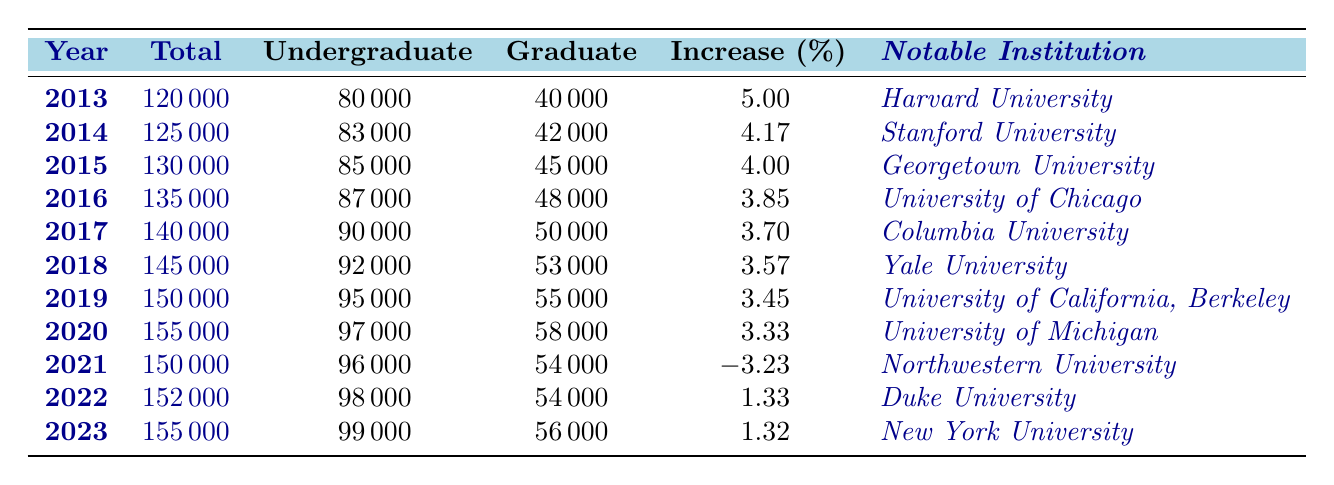What was the total enrollment in 2016? The table shows that the total enrollment for the year 2016 is indicated in the relevant row. It lists "135000" as the total enrollment figure for that year.
Answer: 135000 Which institution had the highest enrollment in 2019? By examining the entries, the notable institution for the year 2019 is listed as "University of California, Berkeley," which also has a total enrollment of 150000.
Answer: University of California, Berkeley What is the increase percentage from 2013 to 2014? The increase percentage for 2014 is listed directly in the table. From 2013, a total enrollment of 120000 increased to 125000 in 2014; thus, the increase percentage noted for 2014 is 4.17.
Answer: 4.17 What was the average graduate enrollment over the last decade? To find the average graduate enrollment, sum the graduate enrollments from 2013 to 2023, then divide by the number of years (11). The total is (40000 + 42000 + 45000 + 48000 + 50000 + 53000 + 55000 + 58000 + 54000 + 54000 + 56000) = 606000. Dividing this by 11 gives 606000/11 = 55272.73.
Answer: 55272.73 Did total enrollment decrease in 2021? Looking at the total enrollment values, 2021 shows "150000," while 2020 shows "155000." Since 150000 is less than 155000, this indicates a decrease.
Answer: Yes What were the enrollment trends from 2020 to 2023? The total enrollment for 2020 is 155000, which slightly decreased to 150000 in 2021, then increased to 152000 in 2022, and finally returned to 155000 in 2023. Thus, the trend reflects a drop in 2021 but returns to the same level by 2023.
Answer: Decrease in 2021, then return to 2020 levels by 2023 What is the difference in undergraduate enrollment between 2015 and 2023? The undergraduate enrollment in 2015 is listed as 85000, and in 2023 it is 99000. The difference can be calculated by subtracting 85000 from 99000, which equals 14000.
Answer: 14000 Which year saw the highest total enrollment and what was that figure? The maximum total enrollment figure must be checked across all the years from the table. The year with the highest total enrollment is 2020 at 155000.
Answer: 155000 How did the increase percentage from 2021 to 2022 compare to the previous years? In 2021, the increase percentage is -3.23 indicating a decline from 2020, while in 2022, it is 1.33 showing recovery. This comparison indicates a return to growth after a decline.
Answer: It recovered from a decline 